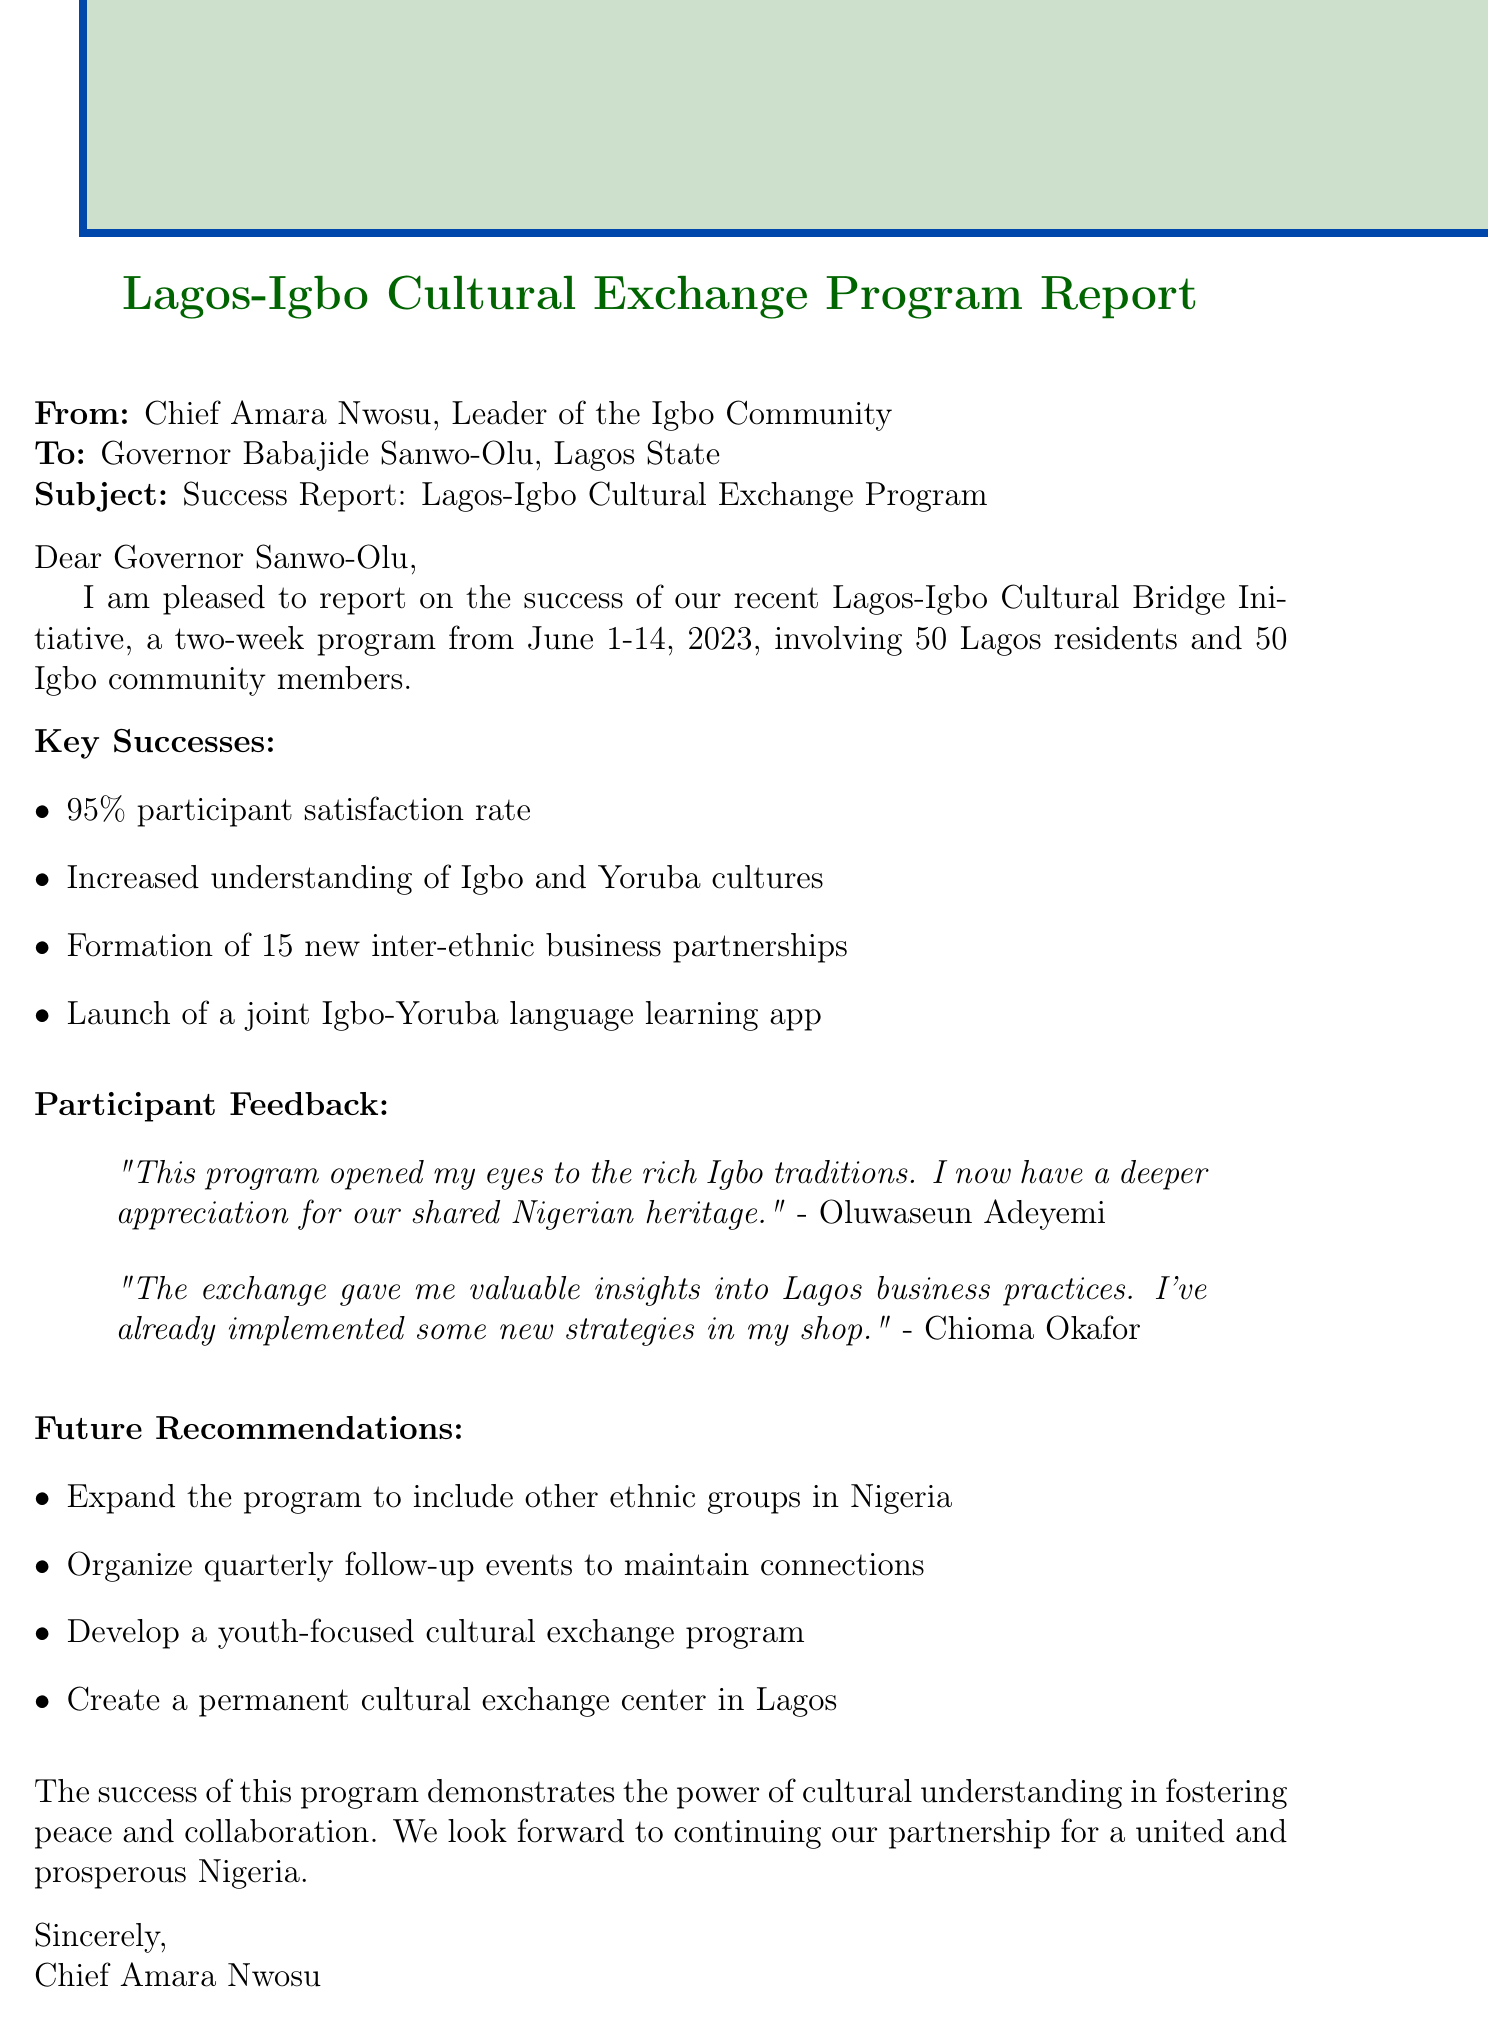What is the program name? The program name is specified in the introduction section of the document.
Answer: Lagos-Igbo Cultural Bridge Initiative How many participants were involved in the program? The document provides information on the total number of participants in the introduction section.
Answer: 100 participants What was the duration of the program? The document explicitly states the program’s duration in the introduction.
Answer: Two-week program What is the participant satisfaction rate? The satisfaction rate is listed as a key success in the document.
Answer: 95% participant satisfaction rate Which language learning app was launched? The document mentions the launch of a language learning app as a key success.
Answer: joint Igbo-Yoruba language learning app Who made a comment about valuing insights into Lagos business practices? The document includes participant feedback with specific names associated with their comments.
Answer: Chioma Okafor What is one recommendation for the future? Future recommendations are provided at the end of the document, and one is requested.
Answer: Expand the program to include other ethnic groups in Nigeria What type of document is this? The structure of the document suggests that it is a communication addressed to a government official concerning a community program.
Answer: Mail What closing statement is in the document? The closing statement encapsulates the program's intent and hope for future collaboration.
Answer: The success of this program demonstrates the power of cultural understanding in fostering peace and collaboration 